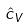<formula> <loc_0><loc_0><loc_500><loc_500>\hat { c } _ { V }</formula> 